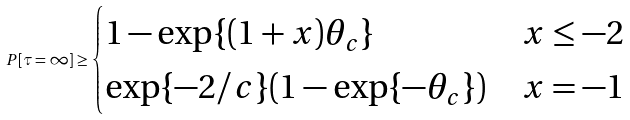Convert formula to latex. <formula><loc_0><loc_0><loc_500><loc_500>P [ \tau = \infty ] \geq \begin{cases} 1 - \exp \{ ( 1 + x ) \theta _ { c } \} & x \leq - 2 \\ \exp \{ - 2 / c \} ( 1 - \exp \{ - \theta _ { c } \} ) & x = - 1 \end{cases}</formula> 